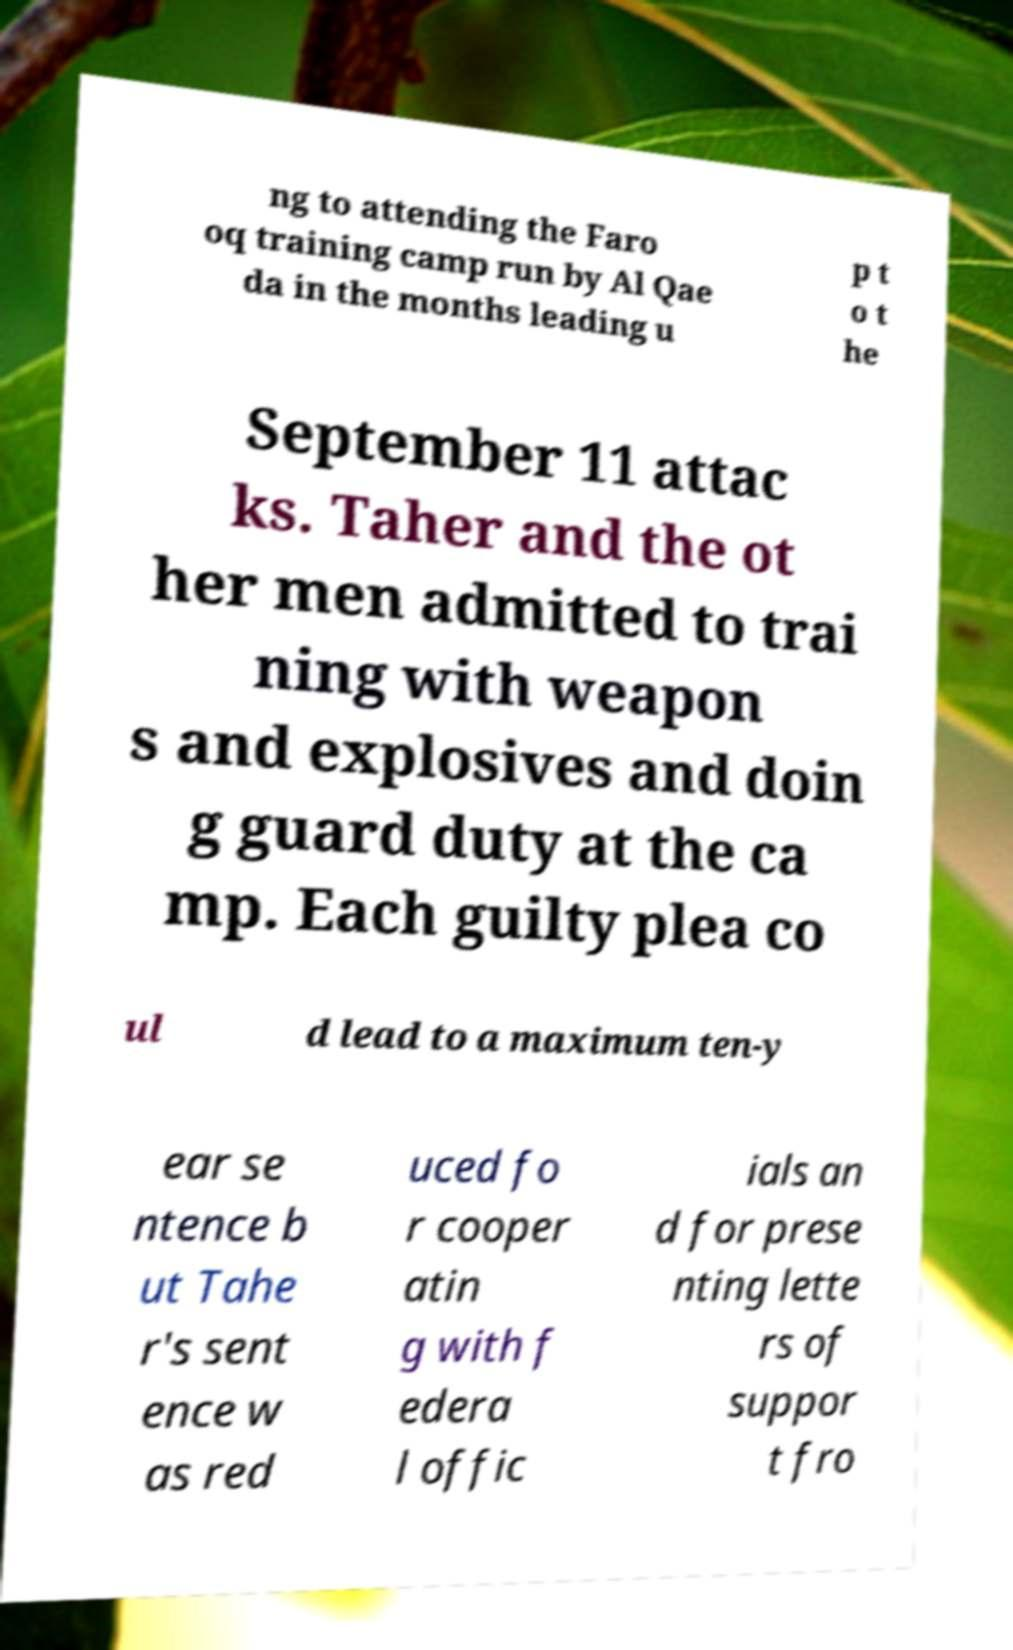Please identify and transcribe the text found in this image. ng to attending the Faro oq training camp run by Al Qae da in the months leading u p t o t he September 11 attac ks. Taher and the ot her men admitted to trai ning with weapon s and explosives and doin g guard duty at the ca mp. Each guilty plea co ul d lead to a maximum ten-y ear se ntence b ut Tahe r's sent ence w as red uced fo r cooper atin g with f edera l offic ials an d for prese nting lette rs of suppor t fro 